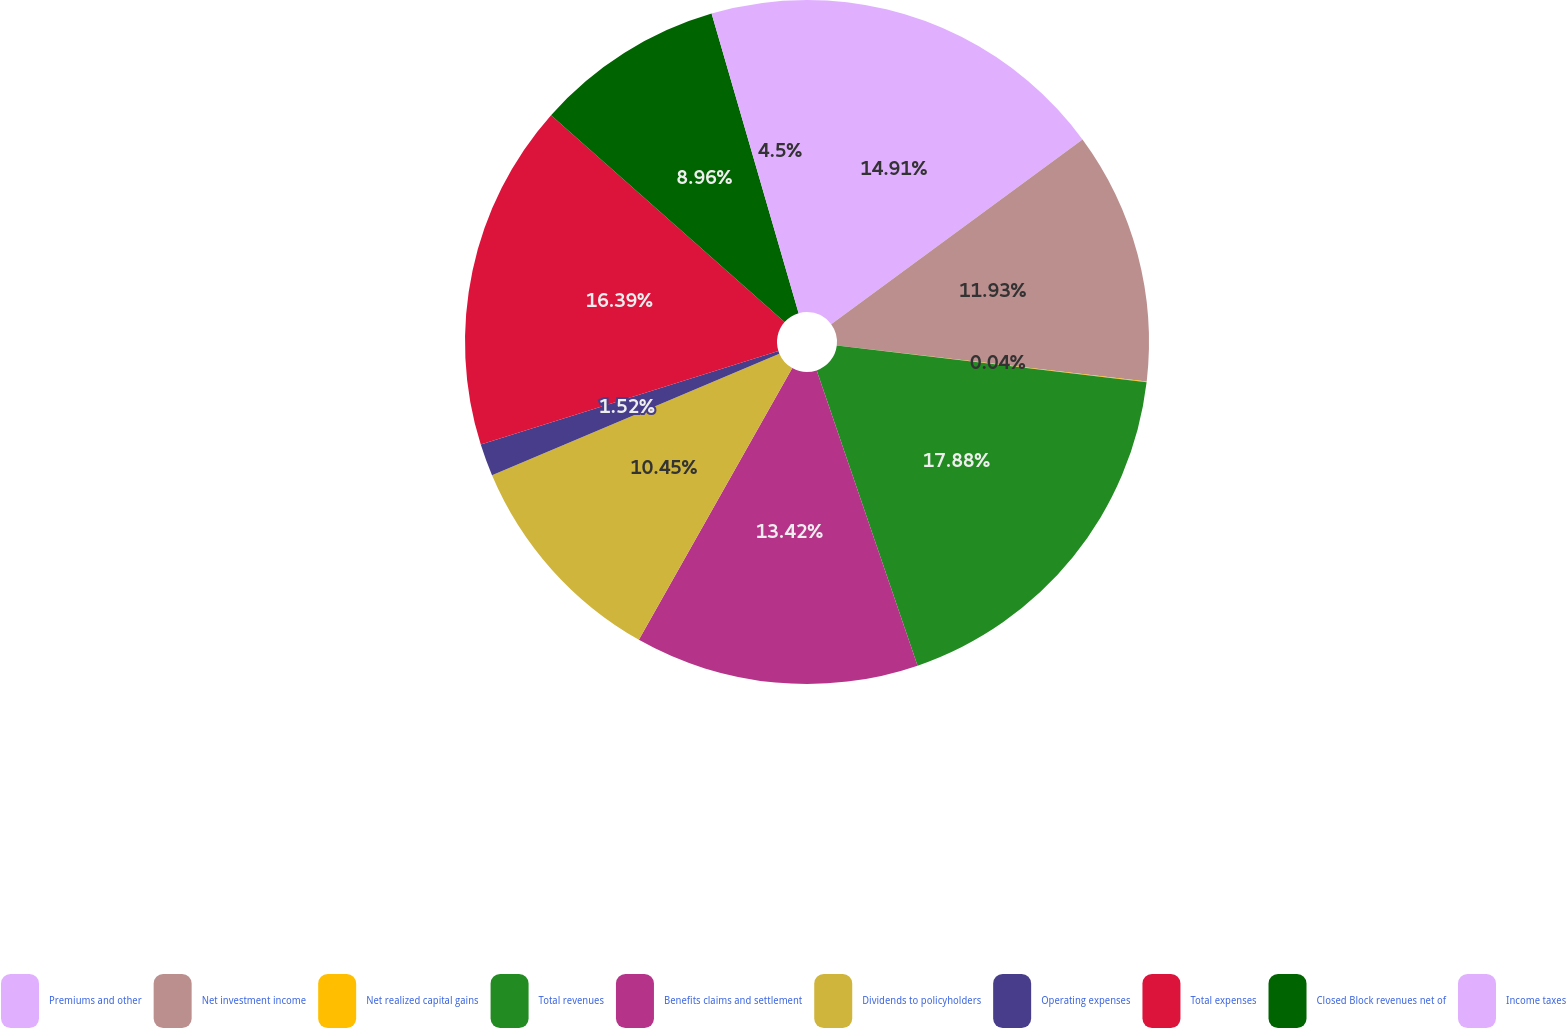Convert chart to OTSL. <chart><loc_0><loc_0><loc_500><loc_500><pie_chart><fcel>Premiums and other<fcel>Net investment income<fcel>Net realized capital gains<fcel>Total revenues<fcel>Benefits claims and settlement<fcel>Dividends to policyholders<fcel>Operating expenses<fcel>Total expenses<fcel>Closed Block revenues net of<fcel>Income taxes<nl><fcel>14.91%<fcel>11.93%<fcel>0.04%<fcel>17.88%<fcel>13.42%<fcel>10.45%<fcel>1.52%<fcel>16.39%<fcel>8.96%<fcel>4.5%<nl></chart> 